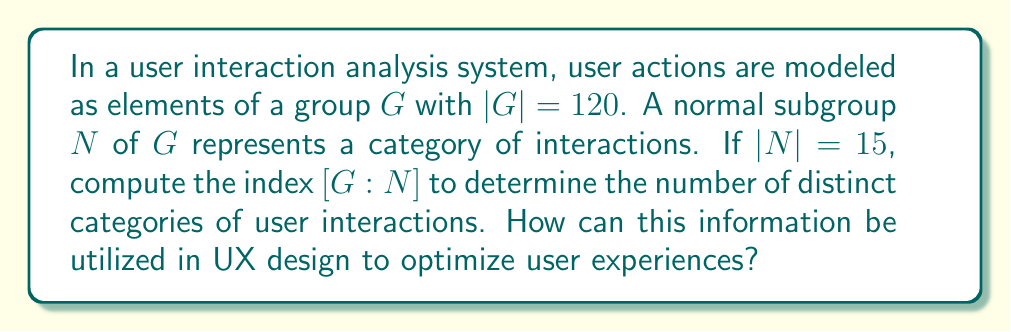Help me with this question. To solve this problem and understand its relevance to UX design, let's break it down step-by-step:

1) The index of a subgroup $N$ in a group $G$, denoted as $[G:N]$, is defined as the number of distinct left (or right) cosets of $N$ in $G$.

2) For finite groups, the index is equal to the quotient of the orders of the group and the subgroup:

   $$[G:N] = \frac{|G|}{|N|}$$

3) We are given:
   - $|G| = 120$ (order of the main group)
   - $|N| = 15$ (order of the normal subgroup)

4) Substituting these values into the formula:

   $$[G:N] = \frac{120}{15} = 8$$

5) Therefore, the index $[G:N]$ is 8.

In the context of UX design:

- The group $G$ represents all possible user interactions in the system.
- The normal subgroup $N$ represents a category of related interactions.
- The index $[G:N] = 8$ indicates that there are 8 distinct categories of user interactions.

This information can be utilized in UX design to:

a) Organize and structure the user interface around these 8 main categories of interactions.
b) Create a navigation system that reflects these distinct categories.
c) Prioritize and optimize the most frequently used categories of interactions.
d) Develop user personas or user journey maps based on these interaction categories.
e) Design consistent interaction patterns within each category to enhance user familiarity and ease of use.

By understanding and leveraging this categorization, UX designers can create more intuitive, efficient, and user-centered interfaces that align with natural user behavior patterns.
Answer: The index $[G:N] = 8$, indicating 8 distinct categories of user interactions. 